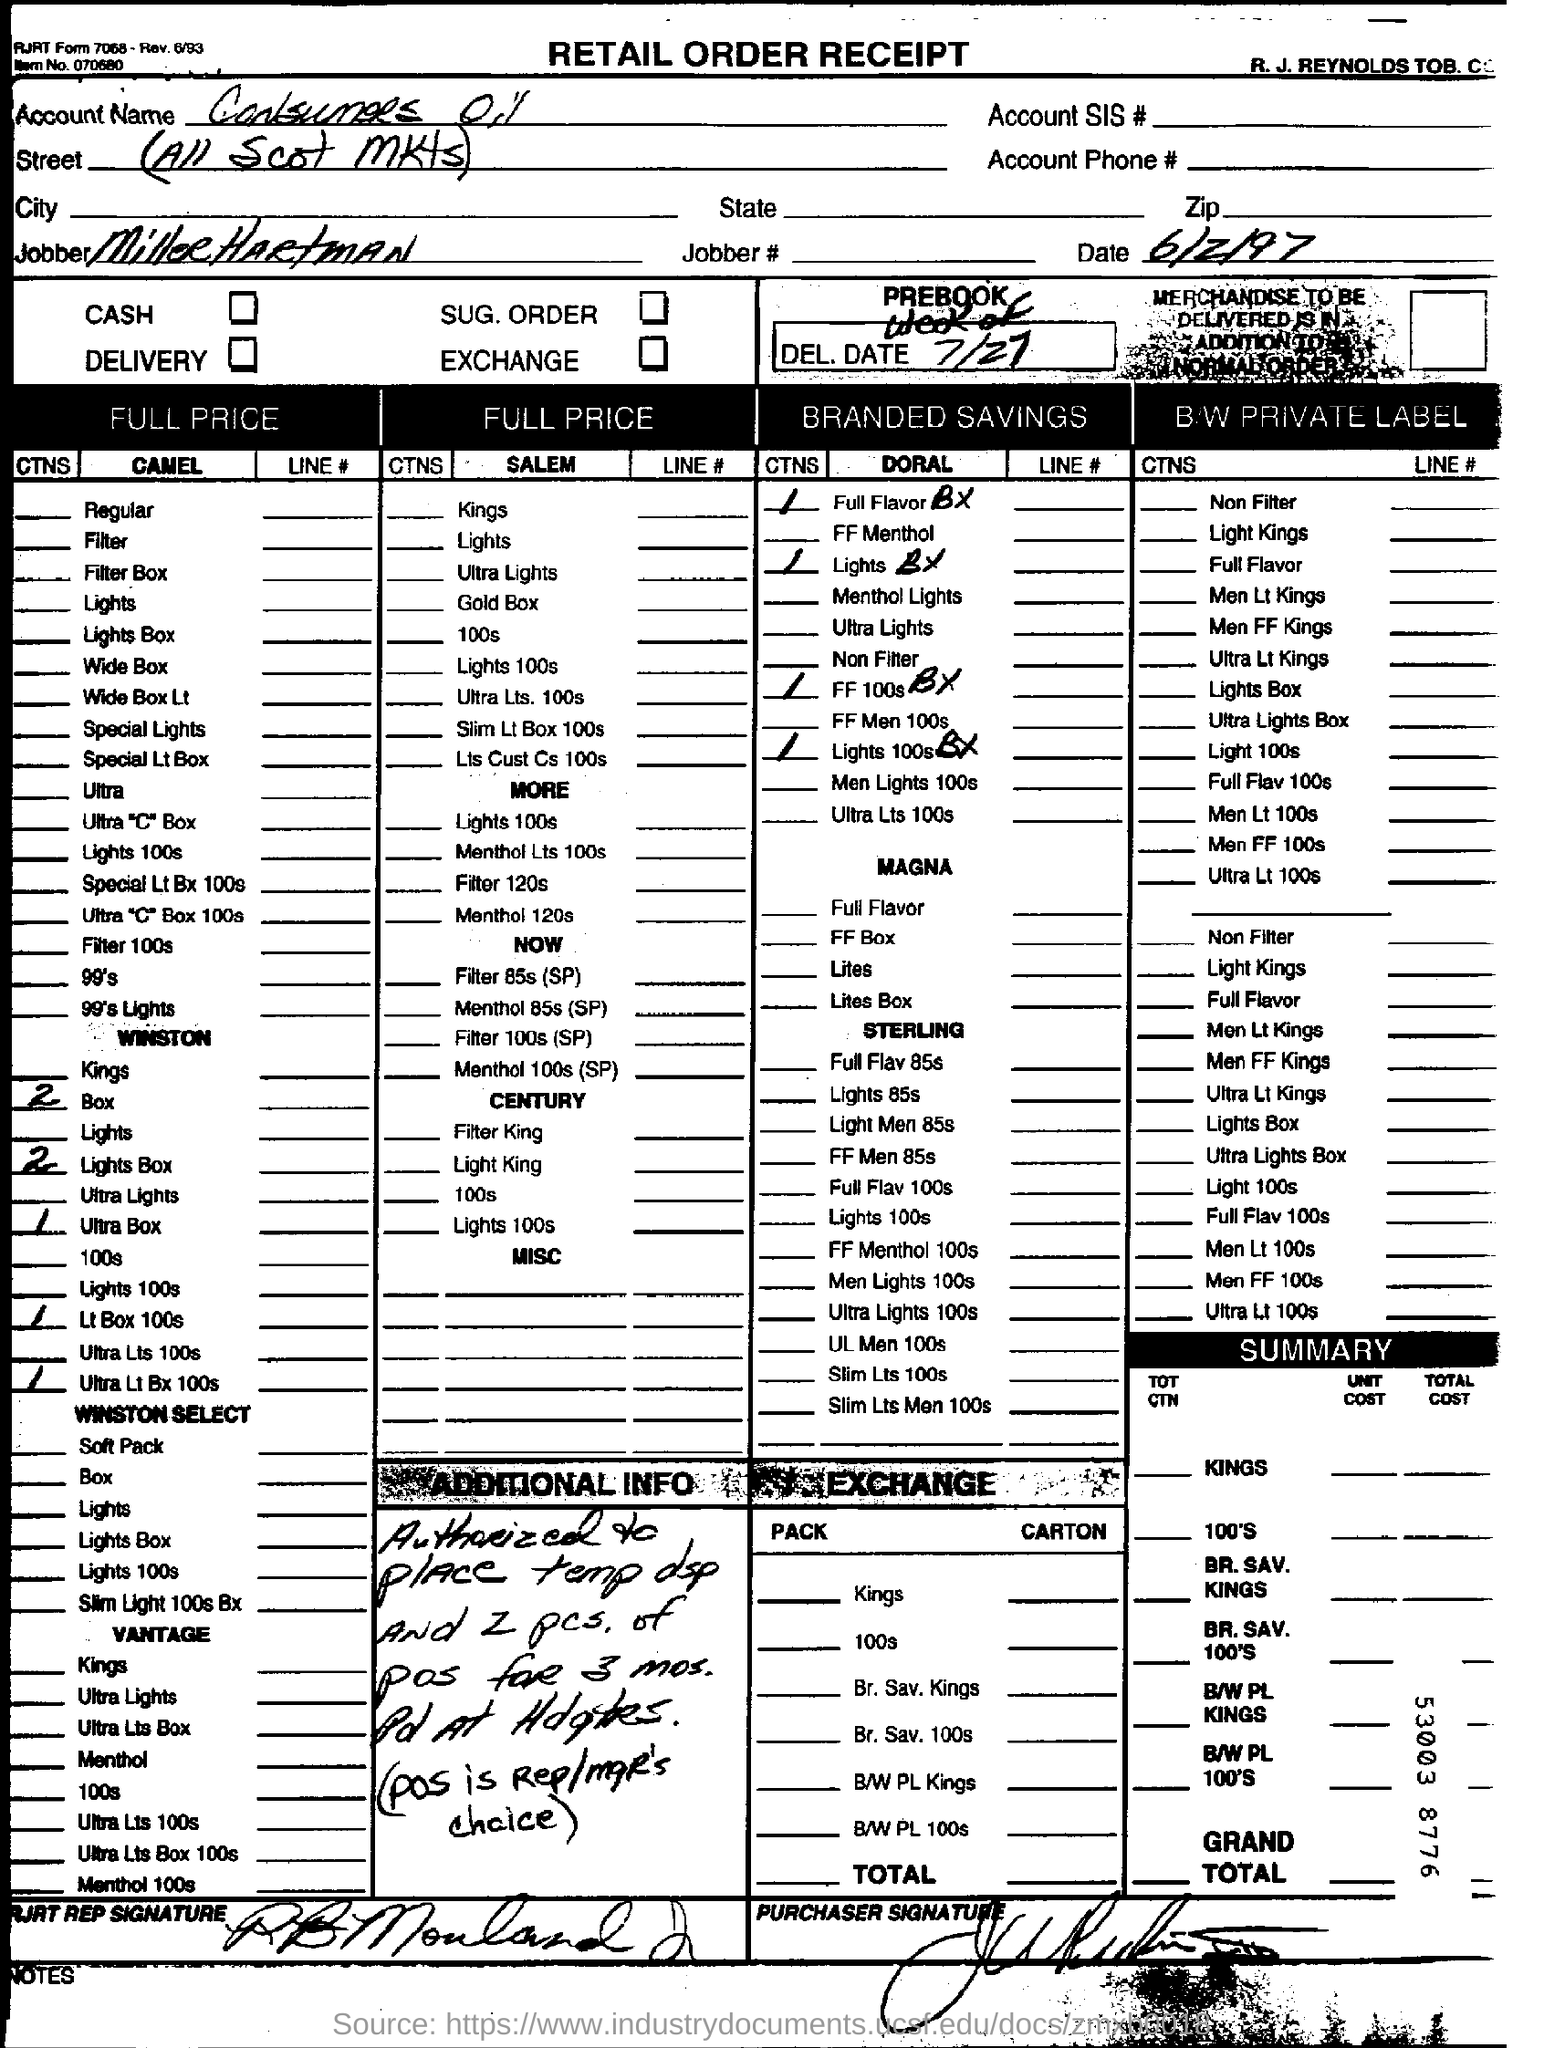Outline some significant characteristics in this image. The date on the document is June 2, 1997. Miller Hartman is the jobber. 